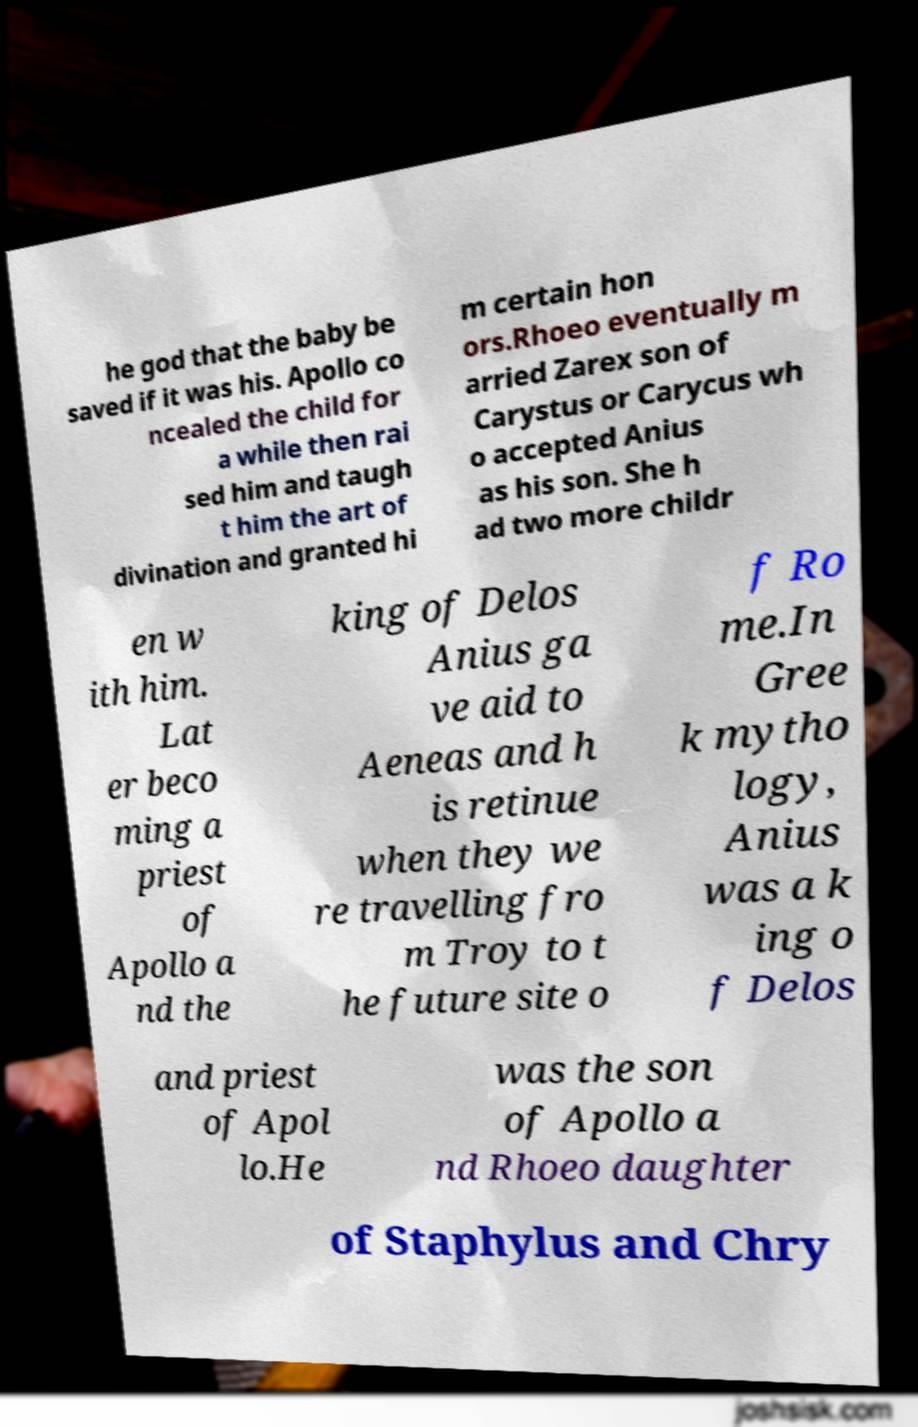For documentation purposes, I need the text within this image transcribed. Could you provide that? he god that the baby be saved if it was his. Apollo co ncealed the child for a while then rai sed him and taugh t him the art of divination and granted hi m certain hon ors.Rhoeo eventually m arried Zarex son of Carystus or Carycus wh o accepted Anius as his son. She h ad two more childr en w ith him. Lat er beco ming a priest of Apollo a nd the king of Delos Anius ga ve aid to Aeneas and h is retinue when they we re travelling fro m Troy to t he future site o f Ro me.In Gree k mytho logy, Anius was a k ing o f Delos and priest of Apol lo.He was the son of Apollo a nd Rhoeo daughter of Staphylus and Chry 